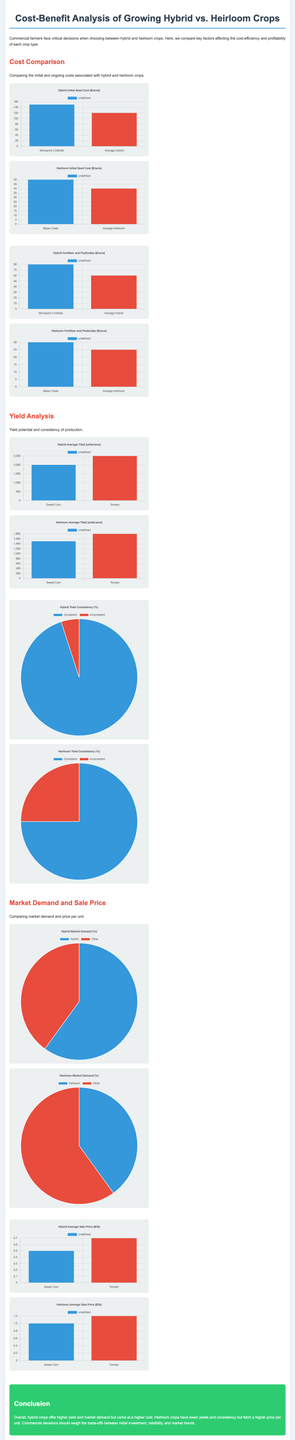What is the initial seed cost for hybrid crops? The document presents the initial seed cost for hybrid crops as represented in the bar chart, which shows $150 for Monsanto's DeKalb and $120 for the average hybrid.
Answer: $150 What is the average yield for heirloom tomatoes? The document provides information about heirloom crop yields, indicating an average yield of 1800 units per acre for heirloom tomatoes.
Answer: 1800 units What percentage of hybrid crops show consistent yield? According to the pie chart, the hybrid yield consistency is represented as 95% consistent yield.
Answer: 95% What is the average sale price per pound for heirloom corn? The document includes a bar chart where the average sale price for heirloom sweet corn is listed as $1.00 per pound.
Answer: $1.00 What is the total market demand for heirloom crops? The pie chart indicates that heirloom crops account for 40% of the market demand when compared to other crops.
Answer: 40% What are the ongoing fertilizer costs for average heirloom crops? The document showcases the ongoing fertilizer and pesticide costs for average heirloom crops, which is represented as $25 per acre.
Answer: $25 